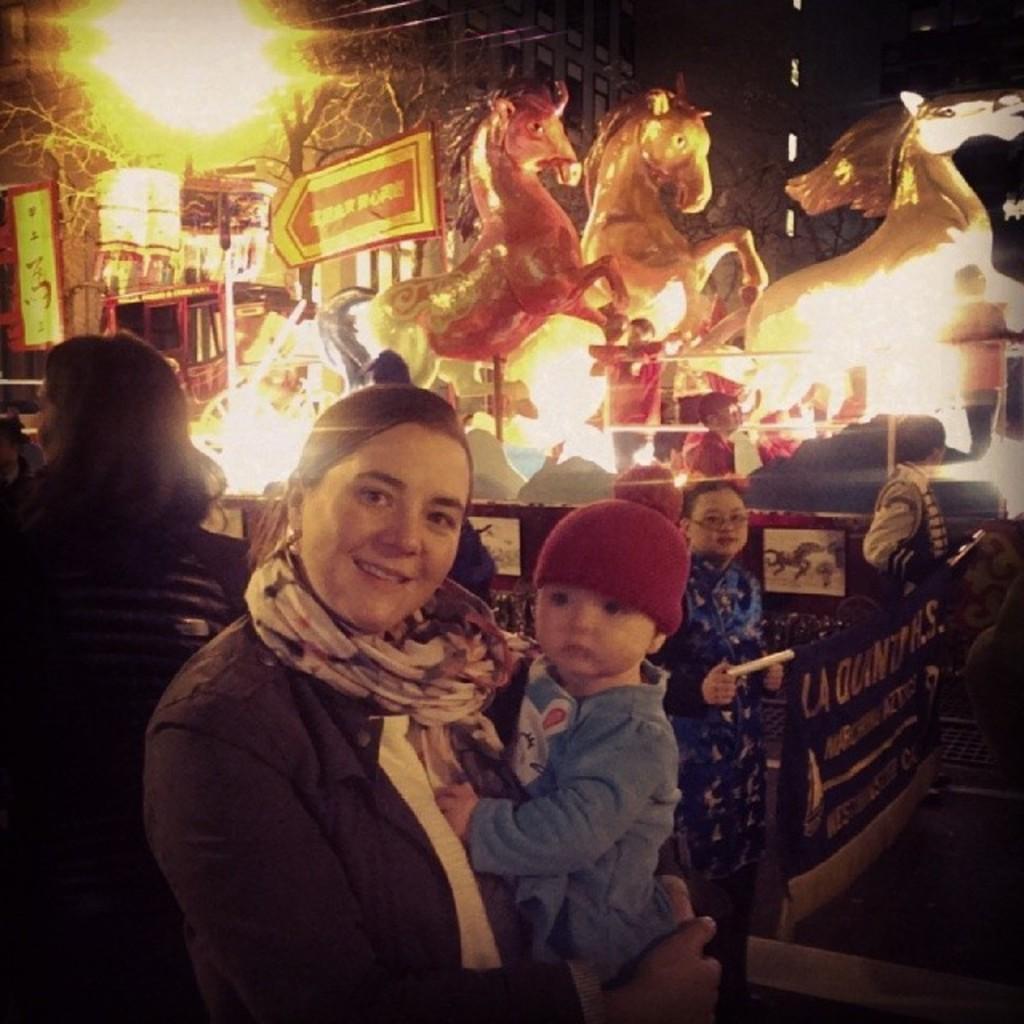How would you summarize this image in a sentence or two? In the middle of the image a woman is standing and holding a baby and smiling. Behind her few people are standing. At the top of the image there are some lights and statues and trees. 